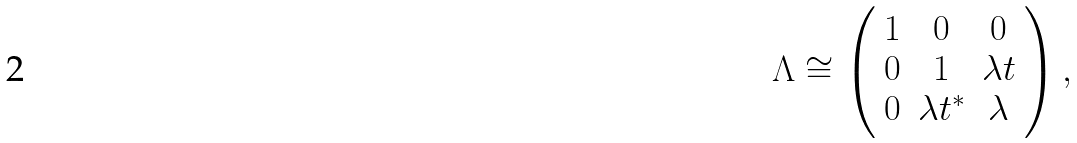<formula> <loc_0><loc_0><loc_500><loc_500>\Lambda \cong \left ( \begin{array} { c c c } 1 & 0 & 0 \\ 0 & 1 & \lambda t \\ 0 & \lambda t ^ { * } & \lambda \end{array} \right ) ,</formula> 